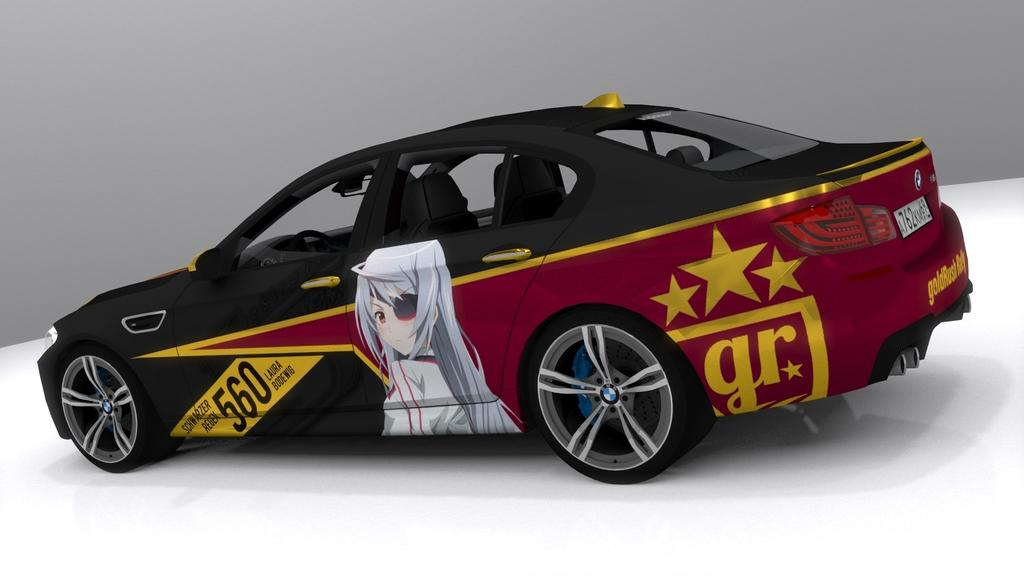What is the main subject of the image? There is a car in the image. What grade is the car in the image? The concept of "grade" does not apply to cars, as it is typically used to describe the level of education or the quality of a product. The image only shows a car, and there is no indication of its educational level or quality. 